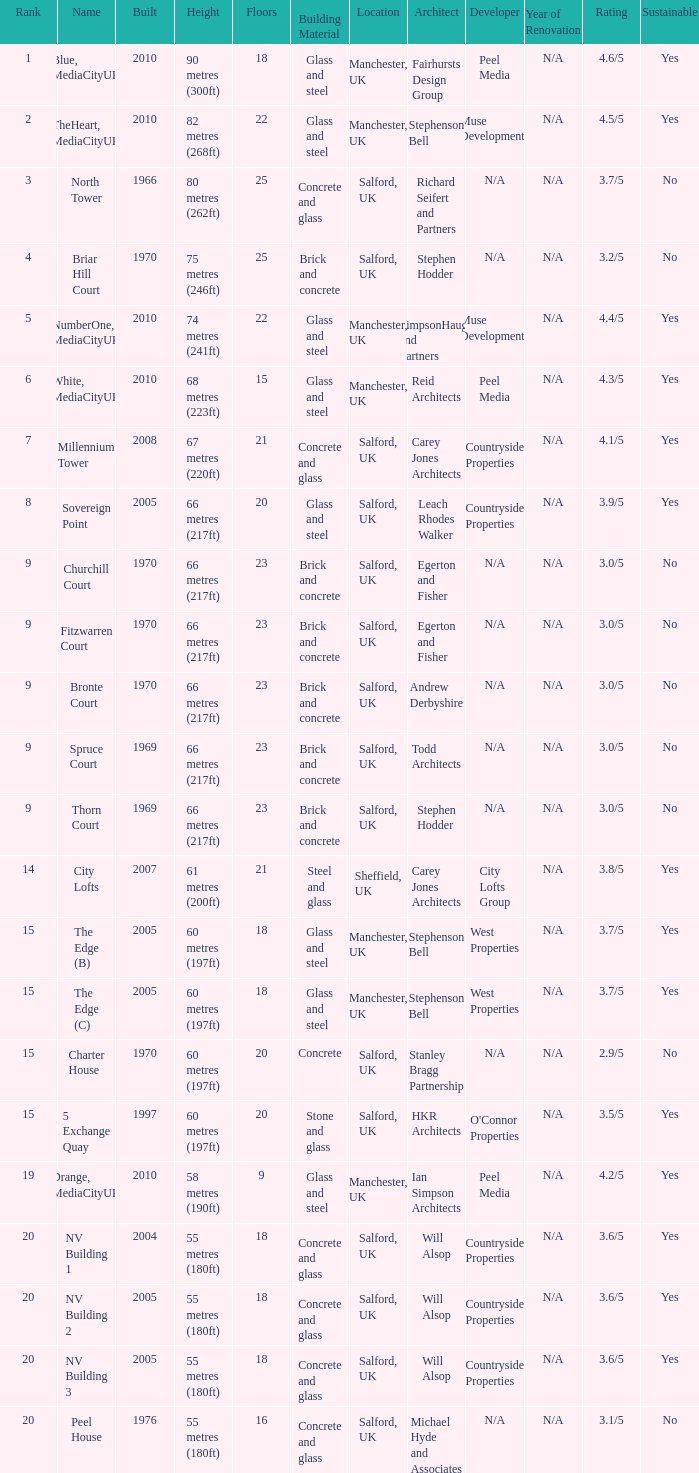What is Height, when Rank is less than 20, when Floors is greater than 9, when Built is 2005, and when Name is The Edge (C)? 60 metres (197ft). 